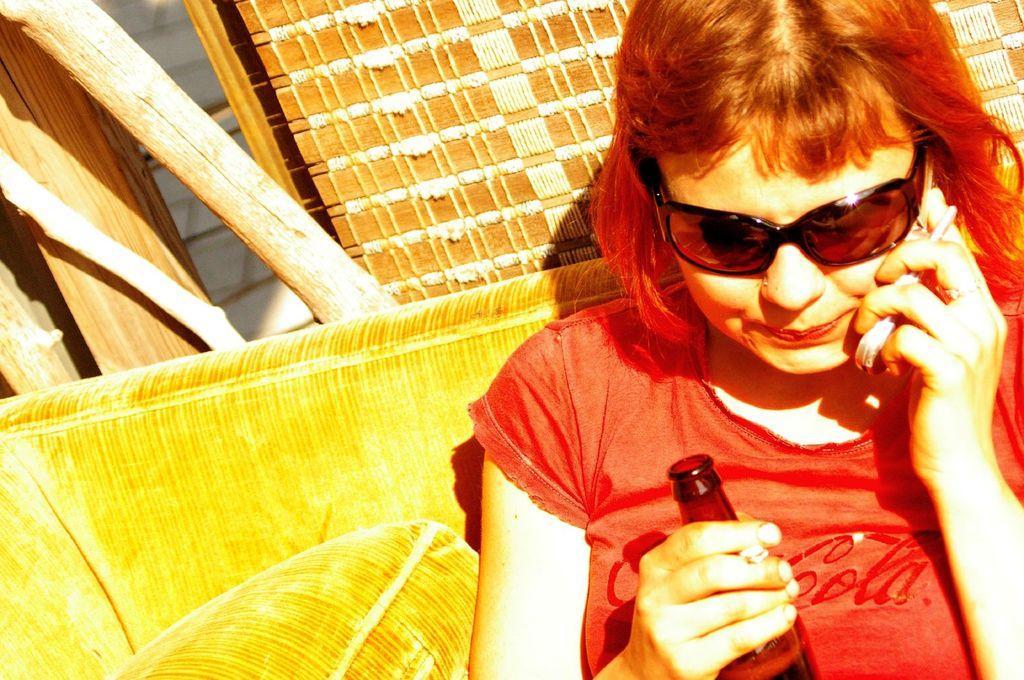Can you describe this image briefly? In this image we can see a woman sitting, wearing sunglasses, talking on the phone and holding a bottle. In the background, we can see some wooden sticks. 